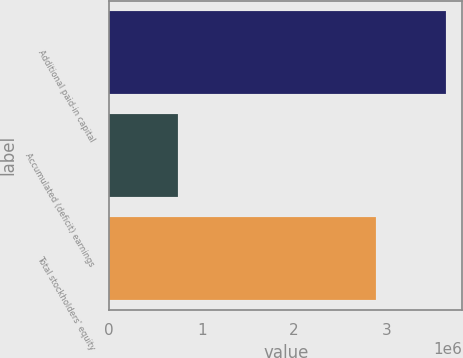Convert chart. <chart><loc_0><loc_0><loc_500><loc_500><bar_chart><fcel>Additional paid-in capital<fcel>Accumulated (deficit) earnings<fcel>Total stockholders' equity<nl><fcel>3.63951e+06<fcel>745151<fcel>2.89197e+06<nl></chart> 